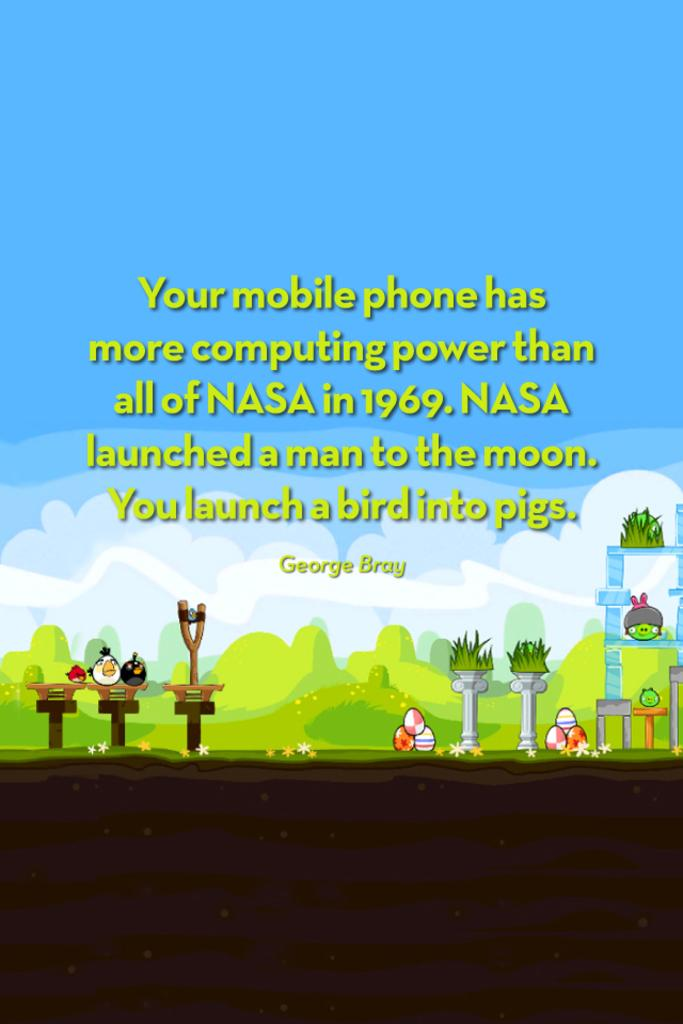<image>
Provide a brief description of the given image. A poster with a quote from George Bray that explains the computing power of your phone is depicted. 